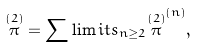Convert formula to latex. <formula><loc_0><loc_0><loc_500><loc_500>\overset { ( 2 ) } { \pi } = \sum \lim i t s _ { n \geq 2 } \overset { ( 2 ) } { \pi } ^ { ( n ) } ,</formula> 